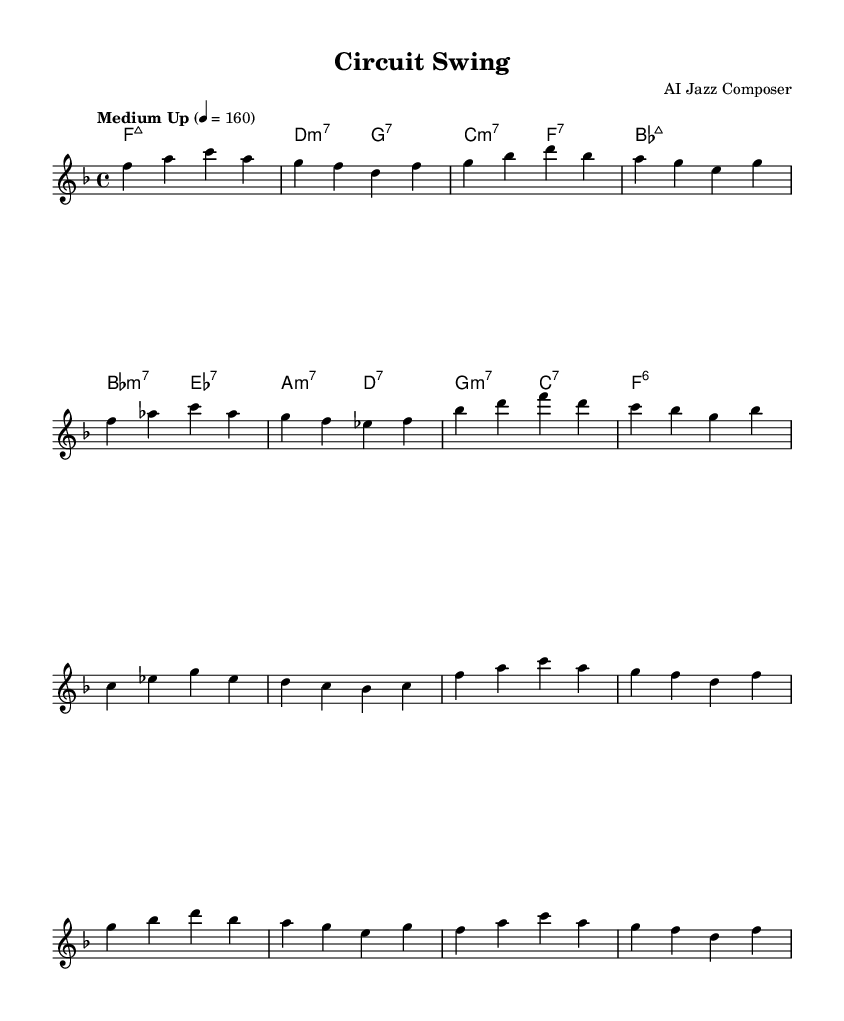What is the key signature of this music? The key signature has one flat (B flat), which indicates that it is in the key of F major.
Answer: F major What is the time signature of this music? The time signature indicated on the sheet music is 4/4, which means there are four beats in each measure and the quarter note gets one beat.
Answer: 4/4 What is the tempo marking for this piece? The tempo marking shown in the music is "Medium Up," with the metronome marking of 160 beats per minute, suggesting a moderately fast pace.
Answer: Medium Up How many bars are in the aSection? By counting the measures in aSection, there are four bars or measures, as each line consists of four beats and fits into a measure.
Answer: 4 Which chord is played at the beginning of the aSection? The chord at the beginning of aSection is F major seven, which is indicated by the chord symbol above the staff.
Answer: Fmaj7 How many different chords are used in the bSection? Upon examining the bSection, there are four different chords that are repeated and varied throughout the measures.
Answer: 4 Is the bSection a repeat of the aSection? The bSection follows a similar pattern but is not an exact repeat; it includes variations in melody and rhythm that distinguish it from the aSection.
Answer: No 